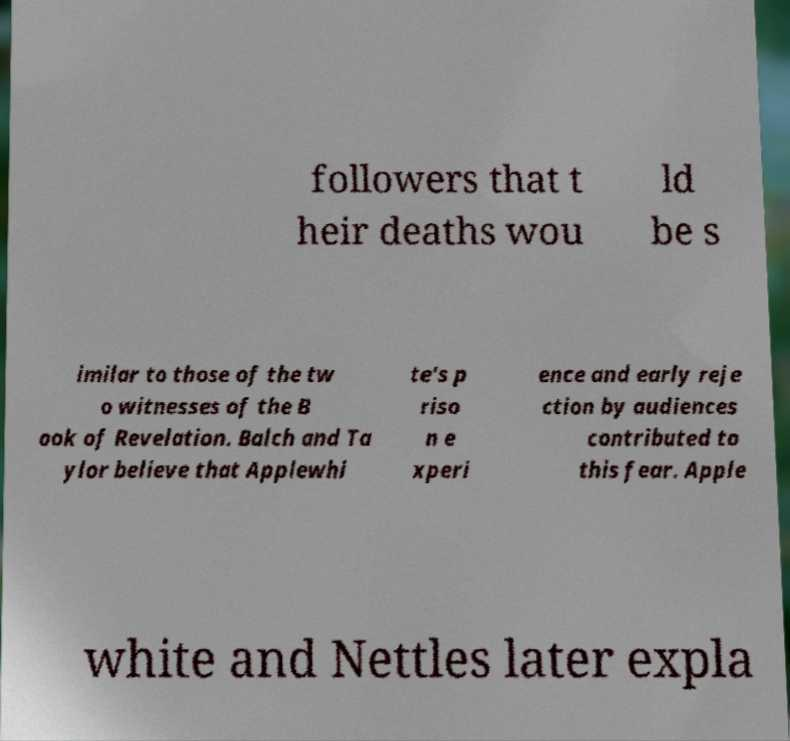Please identify and transcribe the text found in this image. followers that t heir deaths wou ld be s imilar to those of the tw o witnesses of the B ook of Revelation. Balch and Ta ylor believe that Applewhi te's p riso n e xperi ence and early reje ction by audiences contributed to this fear. Apple white and Nettles later expla 